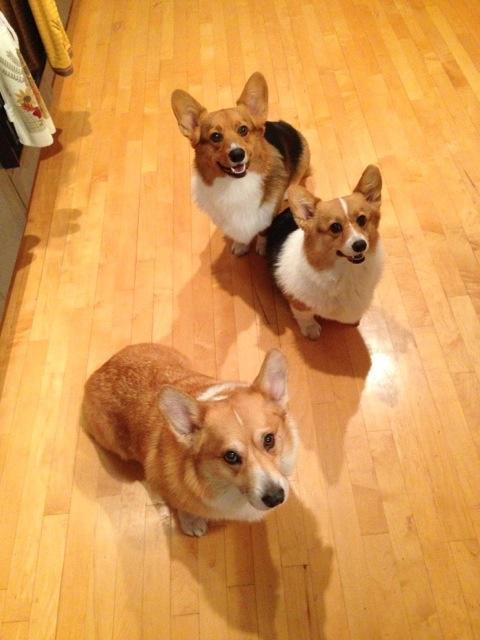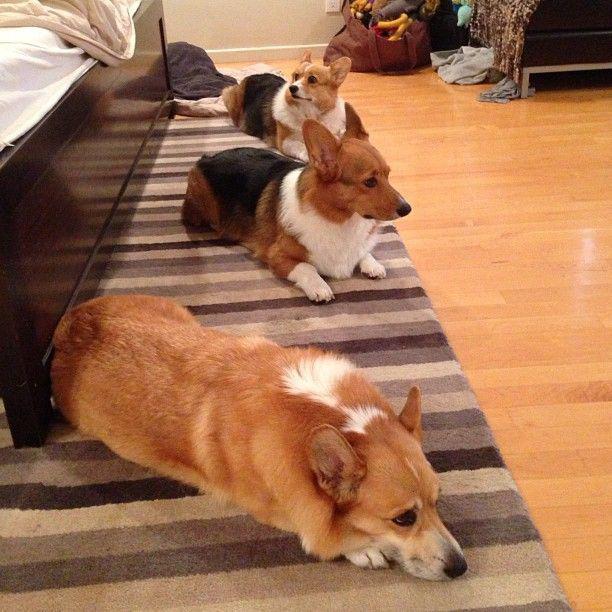The first image is the image on the left, the second image is the image on the right. For the images shown, is this caption "There are at most four dogs." true? Answer yes or no. No. The first image is the image on the left, the second image is the image on the right. Examine the images to the left and right. Is the description "There are no more than two dogs in the left image." accurate? Answer yes or no. No. 